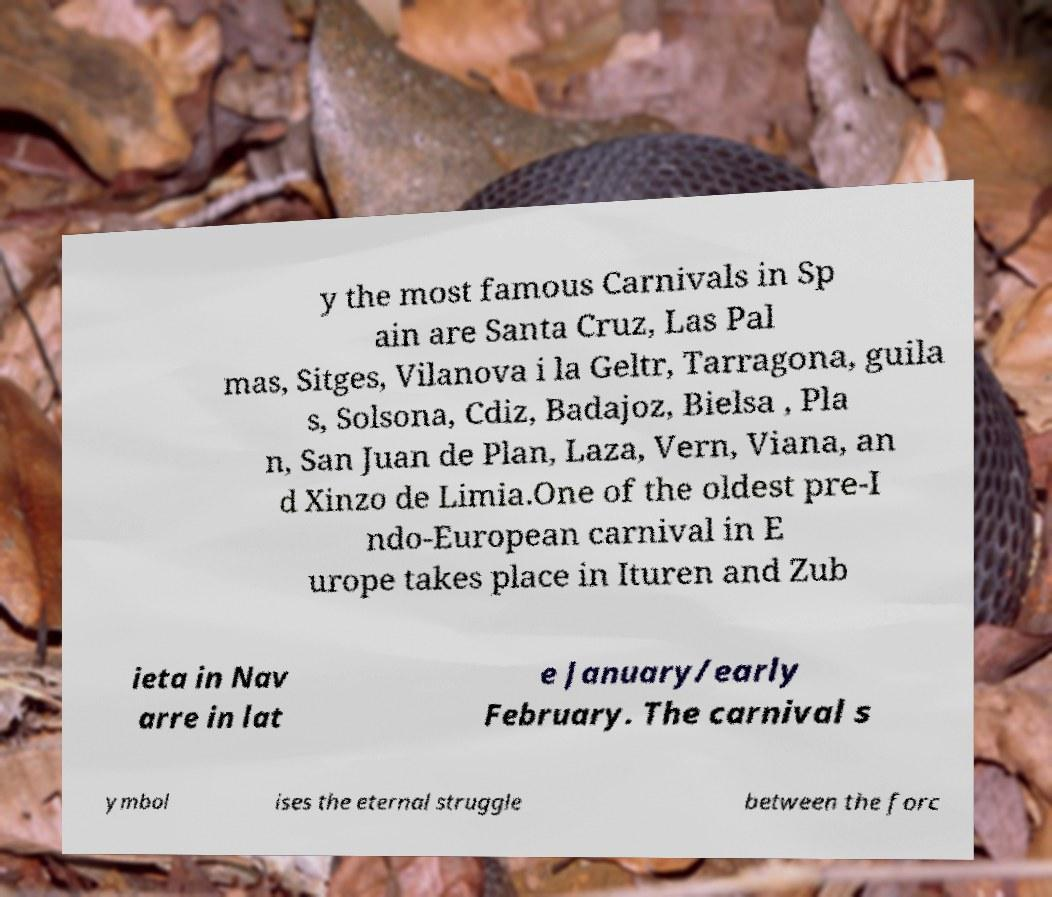There's text embedded in this image that I need extracted. Can you transcribe it verbatim? y the most famous Carnivals in Sp ain are Santa Cruz, Las Pal mas, Sitges, Vilanova i la Geltr, Tarragona, guila s, Solsona, Cdiz, Badajoz, Bielsa , Pla n, San Juan de Plan, Laza, Vern, Viana, an d Xinzo de Limia.One of the oldest pre-I ndo-European carnival in E urope takes place in Ituren and Zub ieta in Nav arre in lat e January/early February. The carnival s ymbol ises the eternal struggle between the forc 